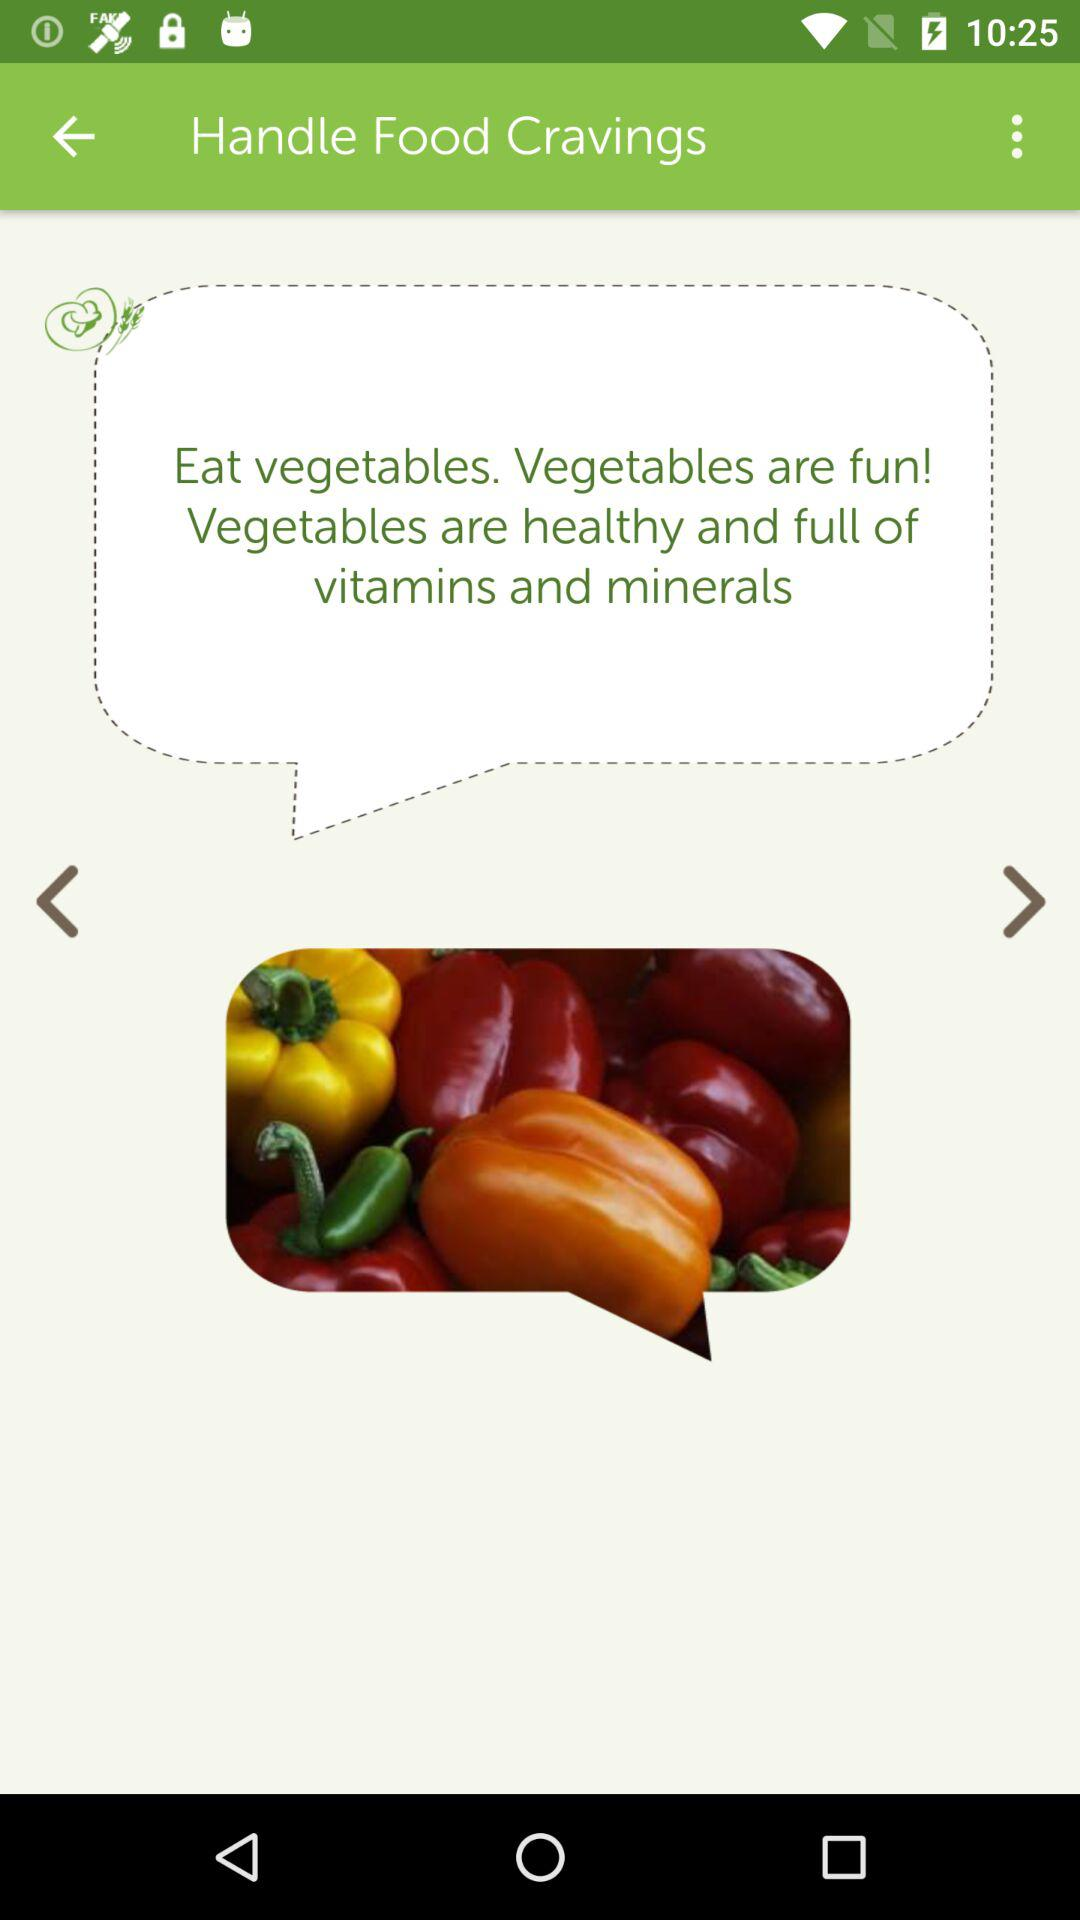What are vegetables full of? Vegetables are full of vitamins and minerals. 